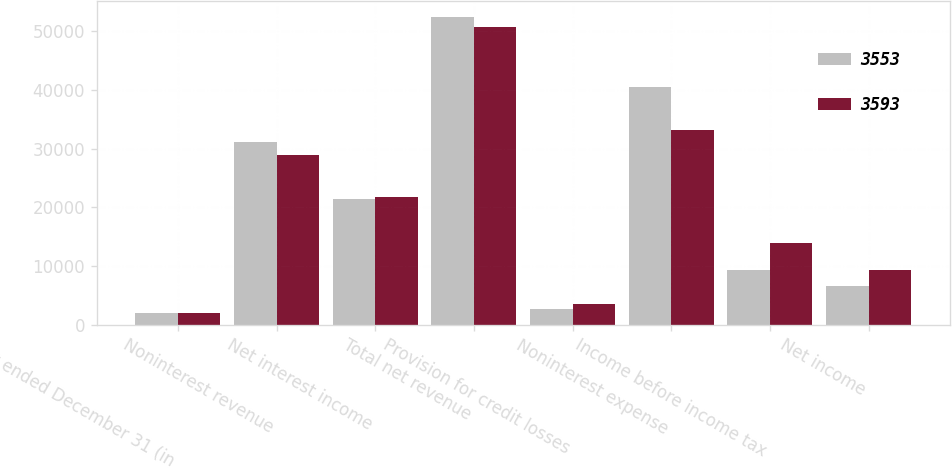<chart> <loc_0><loc_0><loc_500><loc_500><stacked_bar_chart><ecel><fcel>Year ended December 31 (in<fcel>Noninterest revenue<fcel>Net interest income<fcel>Total net revenue<fcel>Provision for credit losses<fcel>Noninterest expense<fcel>Income before income tax<fcel>Net income<nl><fcel>3553<fcel>2004<fcel>31175<fcel>21366<fcel>52541<fcel>2727<fcel>40504<fcel>9310<fcel>6544<nl><fcel>3593<fcel>2003<fcel>28966<fcel>21715<fcel>50681<fcel>3570<fcel>33136<fcel>13975<fcel>9330<nl></chart> 